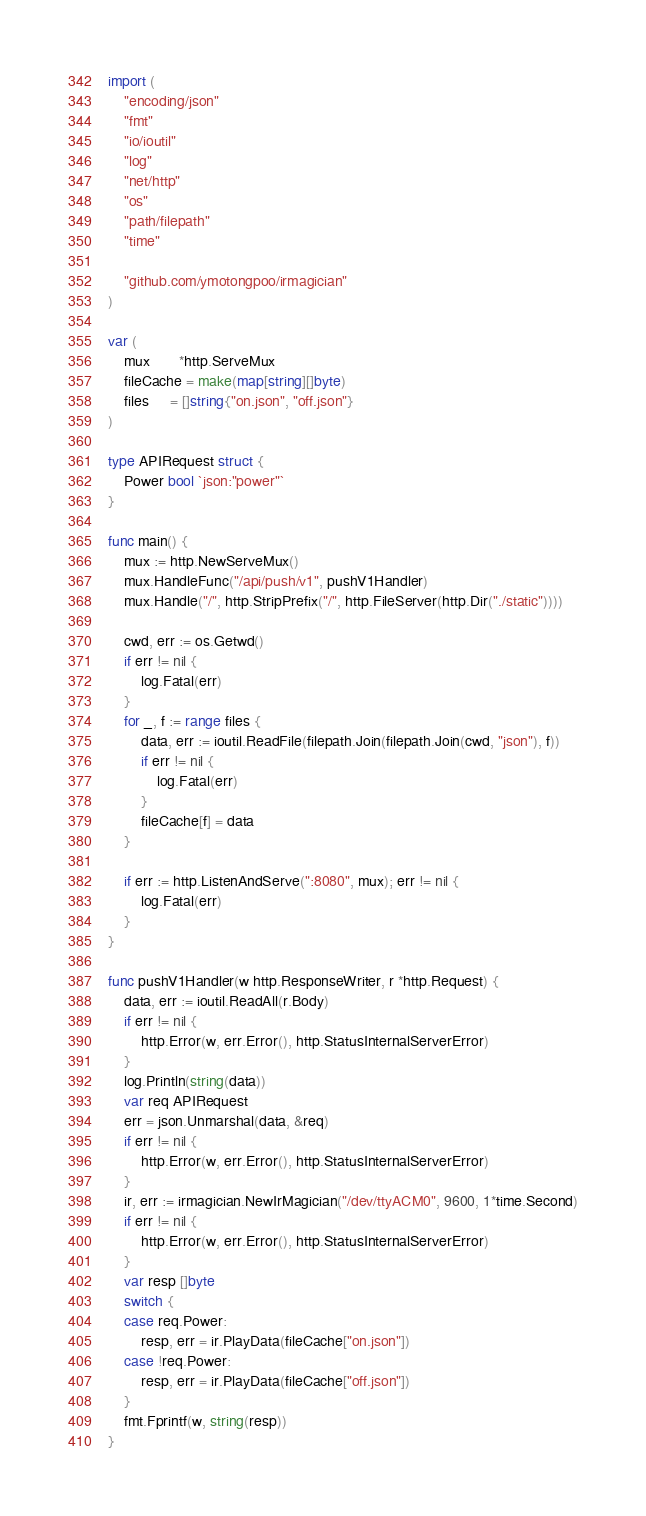Convert code to text. <code><loc_0><loc_0><loc_500><loc_500><_Go_>
import (
	"encoding/json"
	"fmt"
	"io/ioutil"
	"log"
	"net/http"
	"os"
	"path/filepath"
	"time"

	"github.com/ymotongpoo/irmagician"
)

var (
	mux       *http.ServeMux
	fileCache = make(map[string][]byte)
	files     = []string{"on.json", "off.json"}
)

type APIRequest struct {
	Power bool `json:"power"`
}

func main() {
	mux := http.NewServeMux()
	mux.HandleFunc("/api/push/v1", pushV1Handler)
	mux.Handle("/", http.StripPrefix("/", http.FileServer(http.Dir("./static"))))

	cwd, err := os.Getwd()
	if err != nil {
		log.Fatal(err)
	}
	for _, f := range files {
		data, err := ioutil.ReadFile(filepath.Join(filepath.Join(cwd, "json"), f))
		if err != nil {
			log.Fatal(err)
		}
		fileCache[f] = data
	}

	if err := http.ListenAndServe(":8080", mux); err != nil {
		log.Fatal(err)
	}
}

func pushV1Handler(w http.ResponseWriter, r *http.Request) {
	data, err := ioutil.ReadAll(r.Body)
	if err != nil {
		http.Error(w, err.Error(), http.StatusInternalServerError)
	}
	log.Println(string(data))
	var req APIRequest
	err = json.Unmarshal(data, &req)
	if err != nil {
		http.Error(w, err.Error(), http.StatusInternalServerError)
	}
	ir, err := irmagician.NewIrMagician("/dev/ttyACM0", 9600, 1*time.Second)
	if err != nil {
		http.Error(w, err.Error(), http.StatusInternalServerError)
	}
	var resp []byte
	switch {
	case req.Power:
		resp, err = ir.PlayData(fileCache["on.json"])
	case !req.Power:
		resp, err = ir.PlayData(fileCache["off.json"])
	}
	fmt.Fprintf(w, string(resp))
}
</code> 